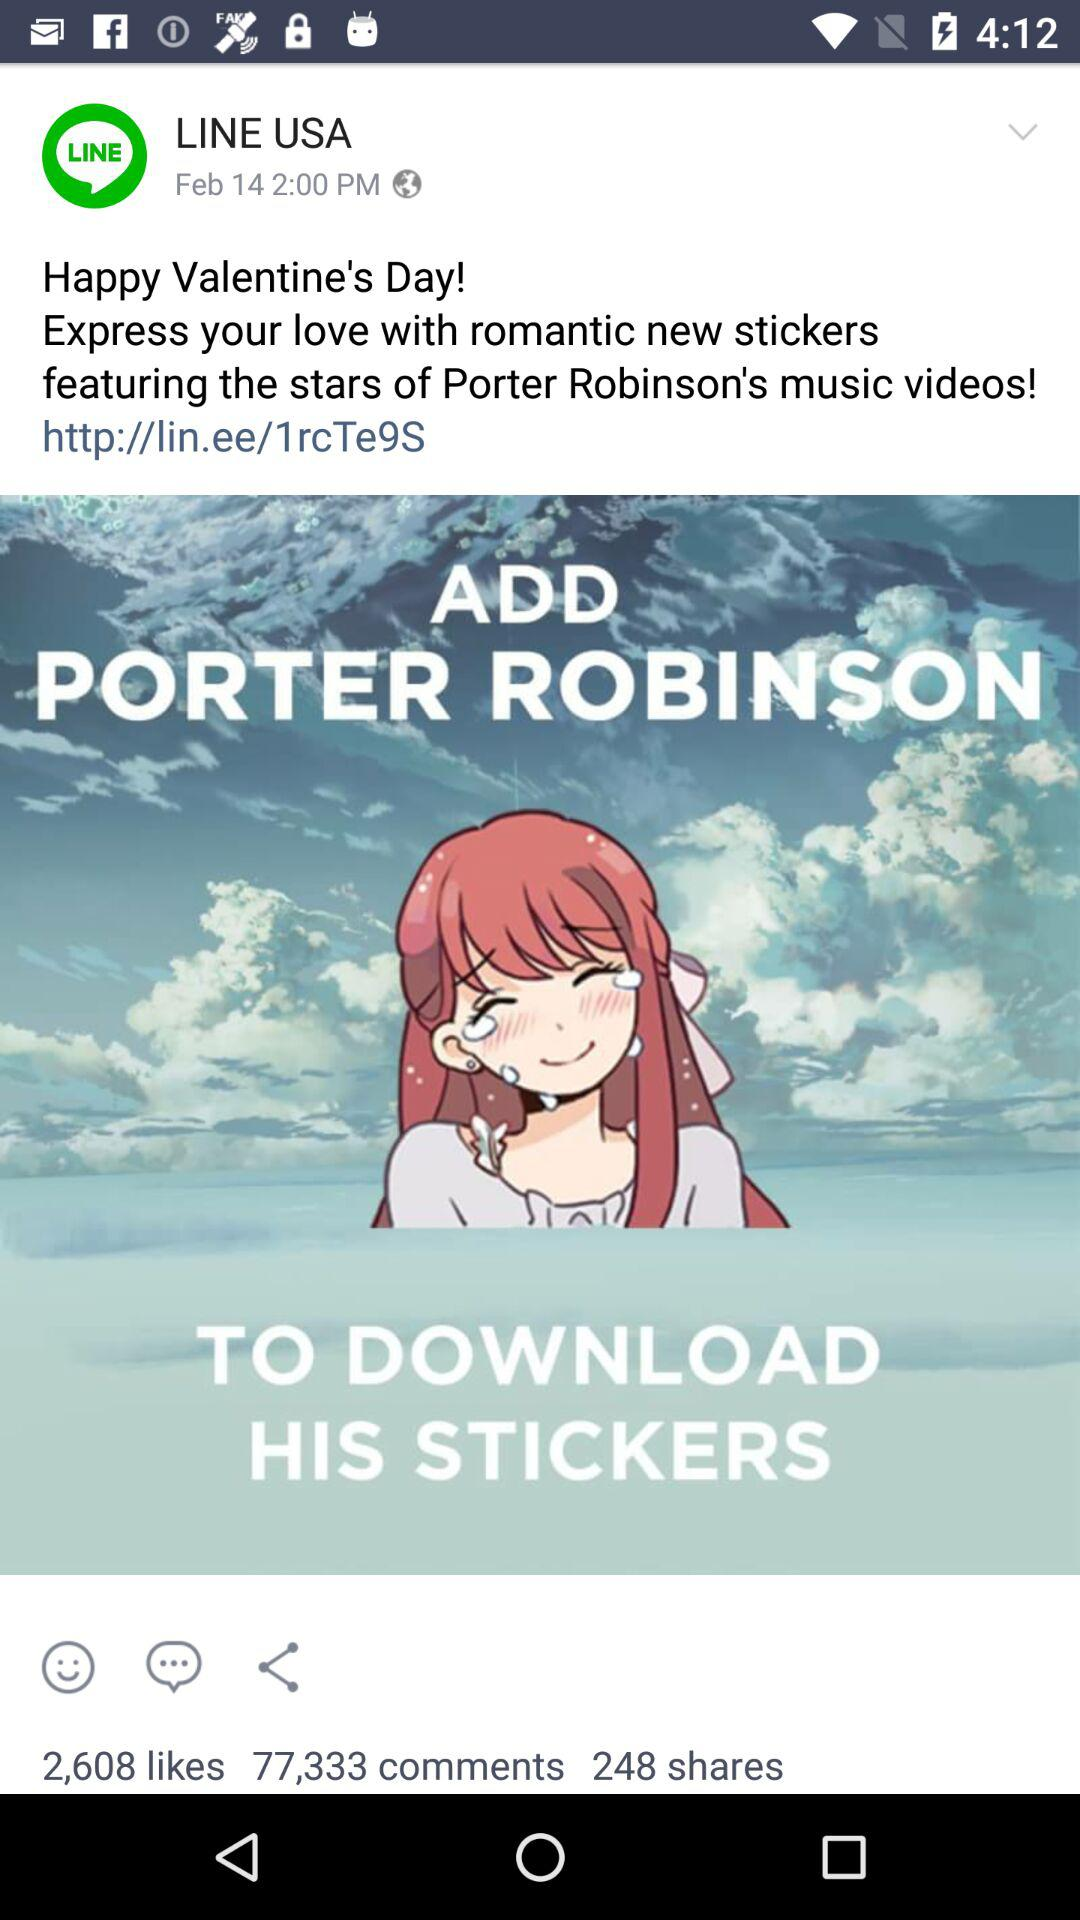How many comments did the sticker post get? The post got 77,333 comments. 